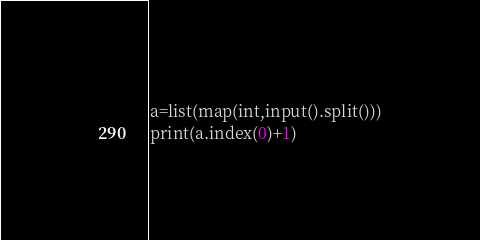Convert code to text. <code><loc_0><loc_0><loc_500><loc_500><_Python_>a=list(map(int,input().split()))
print(a.index(0)+1)</code> 